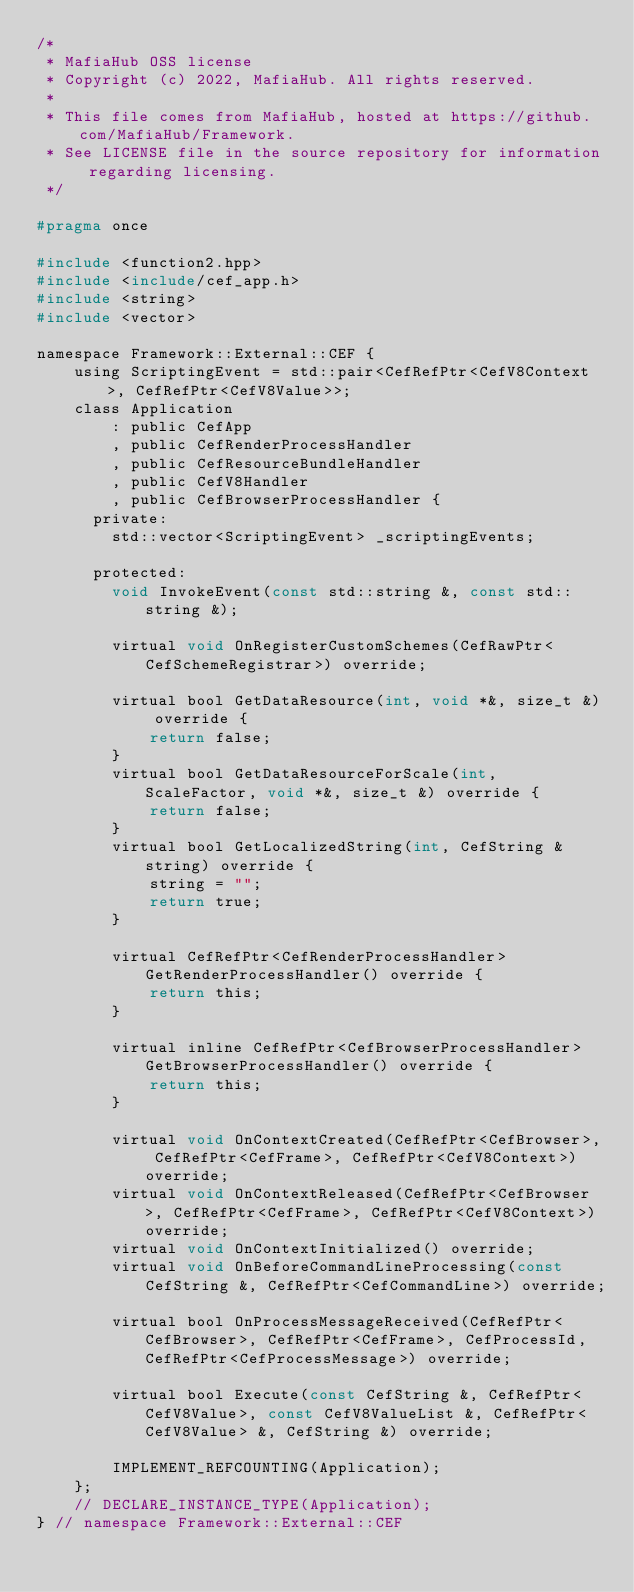<code> <loc_0><loc_0><loc_500><loc_500><_C_>/*
 * MafiaHub OSS license
 * Copyright (c) 2022, MafiaHub. All rights reserved.
 *
 * This file comes from MafiaHub, hosted at https://github.com/MafiaHub/Framework.
 * See LICENSE file in the source repository for information regarding licensing.
 */

#pragma once

#include <function2.hpp>
#include <include/cef_app.h>
#include <string>
#include <vector>

namespace Framework::External::CEF {
    using ScriptingEvent = std::pair<CefRefPtr<CefV8Context>, CefRefPtr<CefV8Value>>;
    class Application
        : public CefApp
        , public CefRenderProcessHandler
        , public CefResourceBundleHandler
        , public CefV8Handler
        , public CefBrowserProcessHandler {
      private:
        std::vector<ScriptingEvent> _scriptingEvents;

      protected:
        void InvokeEvent(const std::string &, const std::string &);

        virtual void OnRegisterCustomSchemes(CefRawPtr<CefSchemeRegistrar>) override;

        virtual bool GetDataResource(int, void *&, size_t &) override {
            return false;
        }
        virtual bool GetDataResourceForScale(int, ScaleFactor, void *&, size_t &) override {
            return false;
        }
        virtual bool GetLocalizedString(int, CefString &string) override {
            string = "";
            return true;
        }

        virtual CefRefPtr<CefRenderProcessHandler> GetRenderProcessHandler() override {
            return this;
        }

        virtual inline CefRefPtr<CefBrowserProcessHandler> GetBrowserProcessHandler() override {
            return this;
        }

        virtual void OnContextCreated(CefRefPtr<CefBrowser>, CefRefPtr<CefFrame>, CefRefPtr<CefV8Context>) override;
        virtual void OnContextReleased(CefRefPtr<CefBrowser>, CefRefPtr<CefFrame>, CefRefPtr<CefV8Context>) override;
        virtual void OnContextInitialized() override;
        virtual void OnBeforeCommandLineProcessing(const CefString &, CefRefPtr<CefCommandLine>) override;

        virtual bool OnProcessMessageReceived(CefRefPtr<CefBrowser>, CefRefPtr<CefFrame>, CefProcessId, CefRefPtr<CefProcessMessage>) override;

        virtual bool Execute(const CefString &, CefRefPtr<CefV8Value>, const CefV8ValueList &, CefRefPtr<CefV8Value> &, CefString &) override;

        IMPLEMENT_REFCOUNTING(Application);
    };
    // DECLARE_INSTANCE_TYPE(Application);
} // namespace Framework::External::CEF
</code> 